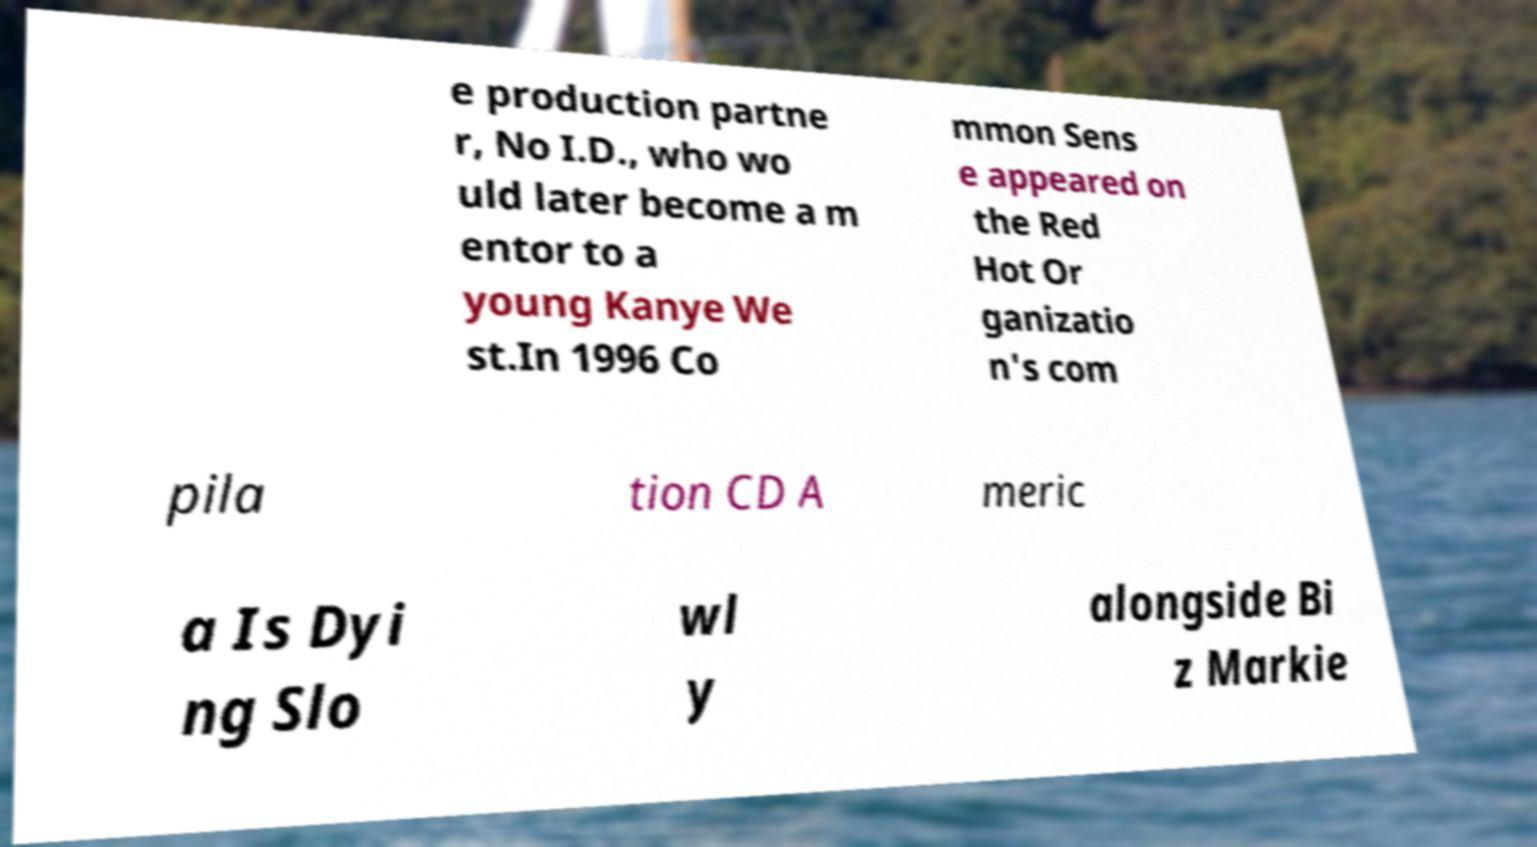Could you assist in decoding the text presented in this image and type it out clearly? e production partne r, No I.D., who wo uld later become a m entor to a young Kanye We st.In 1996 Co mmon Sens e appeared on the Red Hot Or ganizatio n's com pila tion CD A meric a Is Dyi ng Slo wl y alongside Bi z Markie 